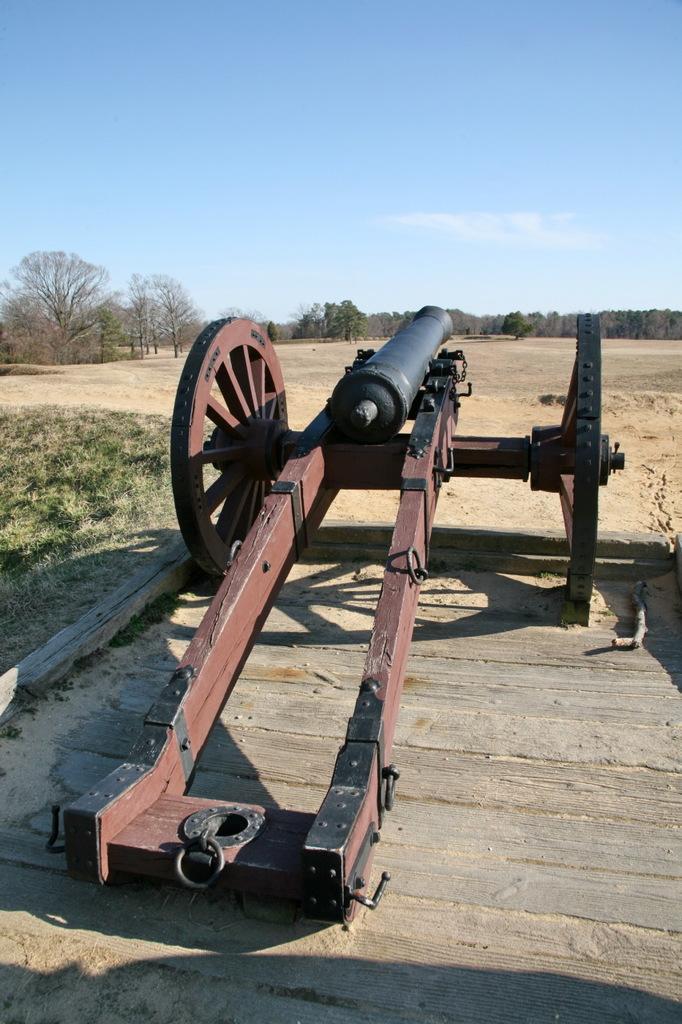Could you give a brief overview of what you see in this image? In this image we can see a cannon on a surface. Behind the cannon we can see a group of trees. At the top we can see the clear sky. 